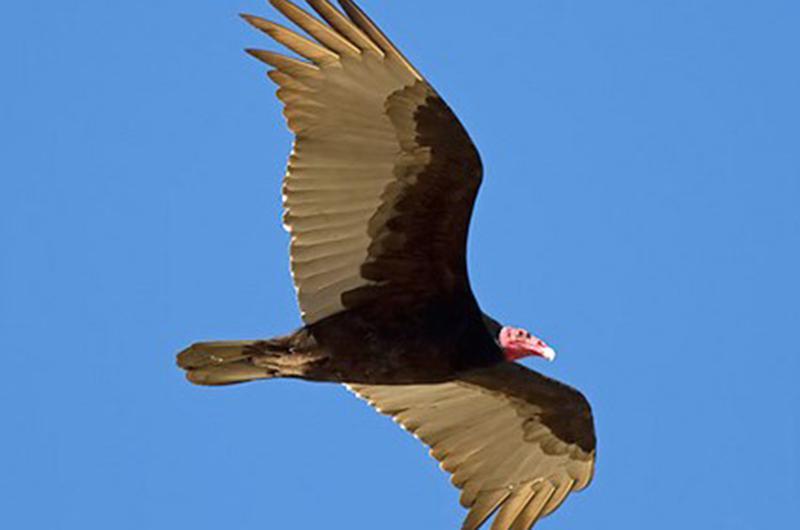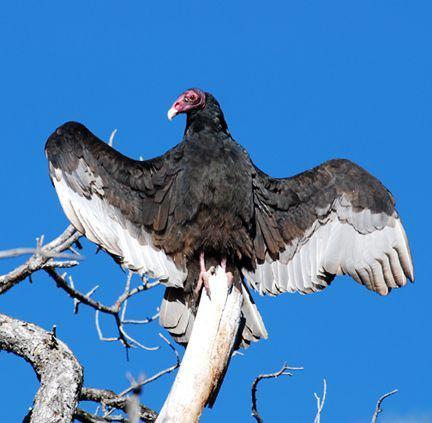The first image is the image on the left, the second image is the image on the right. For the images displayed, is the sentence "A rear-facing vulture is perched on something wooden and has its wings spreading." factually correct? Answer yes or no. Yes. The first image is the image on the left, the second image is the image on the right. Examine the images to the left and right. Is the description "Two birds are close up, while 4 or more birds are flying high in the distance." accurate? Answer yes or no. No. 